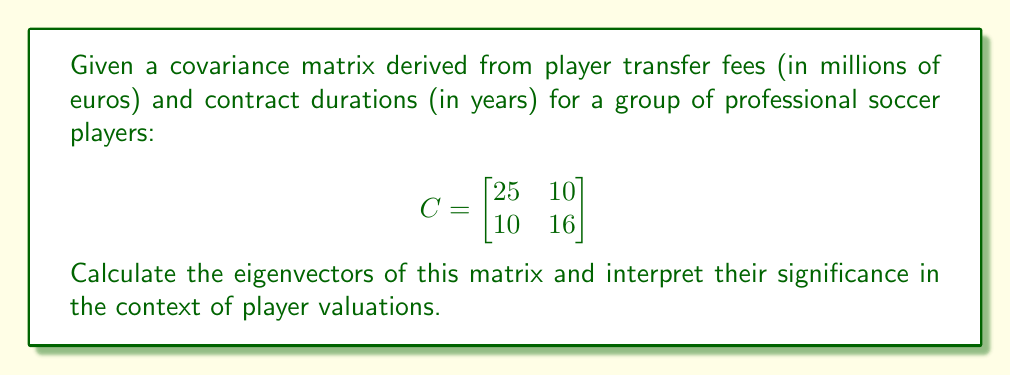Provide a solution to this math problem. To find the eigenvectors of the covariance matrix C, we follow these steps:

1) First, we need to find the eigenvalues by solving the characteristic equation:
   $$det(C - \lambda I) = 0$$

   $$\begin{vmatrix}
   25-\lambda & 10 \\
   10 & 16-\lambda
   \end{vmatrix} = 0$$

   $$(25-\lambda)(16-\lambda) - 100 = 0$$
   
   $$\lambda^2 - 41\lambda + 300 = 0$$

2) Solving this quadratic equation:
   $$\lambda = \frac{41 \pm \sqrt{41^2 - 4(300)}}{2} = \frac{41 \pm \sqrt{481}}{2}$$

   $$\lambda_1 = \frac{41 + 21.93}{2} \approx 31.47$$
   $$\lambda_2 = \frac{41 - 21.93}{2} \approx 9.53$$

3) Now, for each eigenvalue, we solve $(C - \lambda I)v = 0$ to find the corresponding eigenvector:

   For $\lambda_1 \approx 31.47$:
   $$\begin{bmatrix}
   -6.47 & 10 \\
   10 & -15.47
   \end{bmatrix} \begin{bmatrix} v_1 \\ v_2 \end{bmatrix} = \begin{bmatrix} 0 \\ 0 \end{bmatrix}$$

   This gives us: $v_1 \approx 0.84$, $v_2 \approx 0.54$

   For $\lambda_2 \approx 9.53$:
   $$\begin{bmatrix}
   15.47 & 10 \\
   10 & 6.47
   \end{bmatrix} \begin{bmatrix} v_1 \\ v_2 \end{bmatrix} = \begin{bmatrix} 0 \\ 0 \end{bmatrix}$$

   This gives us: $v_1 \approx -0.54$, $v_2 \approx 0.84$

4) Normalizing these vectors, we get our final eigenvectors:
   $$v_1 = \begin{bmatrix} 0.84 \\ 0.54 \end{bmatrix}, v_2 = \begin{bmatrix} -0.54 \\ 0.84 \end{bmatrix}$$

Interpretation: The first eigenvector (0.84, 0.54) represents the direction of maximum variance in the data. It suggests a positive correlation between transfer fees and contract durations. The second eigenvector (-0.54, 0.84) is orthogonal to the first and represents the direction of minimum variance, indicating a trade-off between transfer fees and contract durations when considering secondary factors in player valuations.
Answer: $v_1 = (0.84, 0.54)$, $v_2 = (-0.54, 0.84)$ 